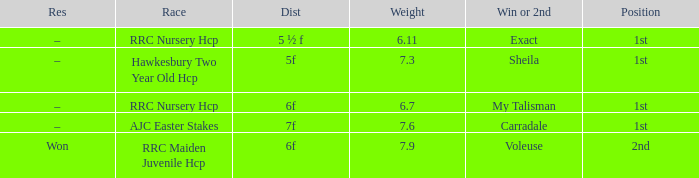What is the the name of the winner or 2nd  with a weight more than 7.3, and the result was –? Carradale. Help me parse the entirety of this table. {'header': ['Res', 'Race', 'Dist', 'Weight', 'Win or 2nd', 'Position'], 'rows': [['–', 'RRC Nursery Hcp', '5 ½ f', '6.11', 'Exact', '1st'], ['–', 'Hawkesbury Two Year Old Hcp', '5f', '7.3', 'Sheila', '1st'], ['–', 'RRC Nursery Hcp', '6f', '6.7', 'My Talisman', '1st'], ['–', 'AJC Easter Stakes', '7f', '7.6', 'Carradale', '1st'], ['Won', 'RRC Maiden Juvenile Hcp', '6f', '7.9', 'Voleuse', '2nd']]} 